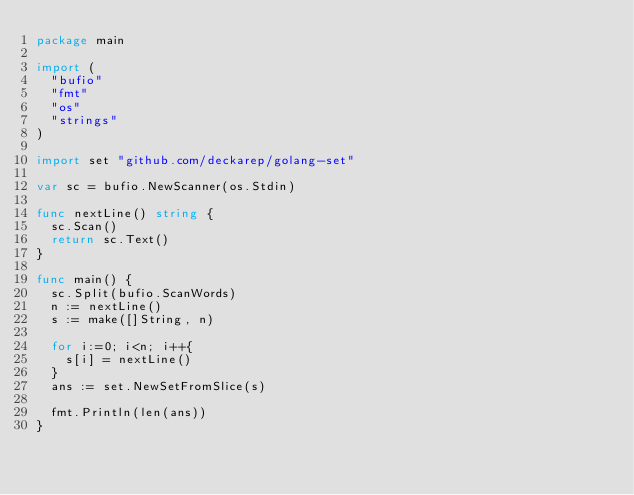Convert code to text. <code><loc_0><loc_0><loc_500><loc_500><_Go_>package main

import (
	"bufio"
	"fmt"
	"os"
	"strings"
)

import set "github.com/deckarep/golang-set"

var sc = bufio.NewScanner(os.Stdin)

func nextLine() string {
	sc.Scan()
	return sc.Text()
}

func main() {
	sc.Split(bufio.ScanWords)
	n := nextLine()
	s := make([]String, n)

	for i:=0; i<n; i++{
		s[i] = nextLine()
	}  
	ans := set.NewSetFromSlice(s)

	fmt.Println(len(ans))
}
</code> 